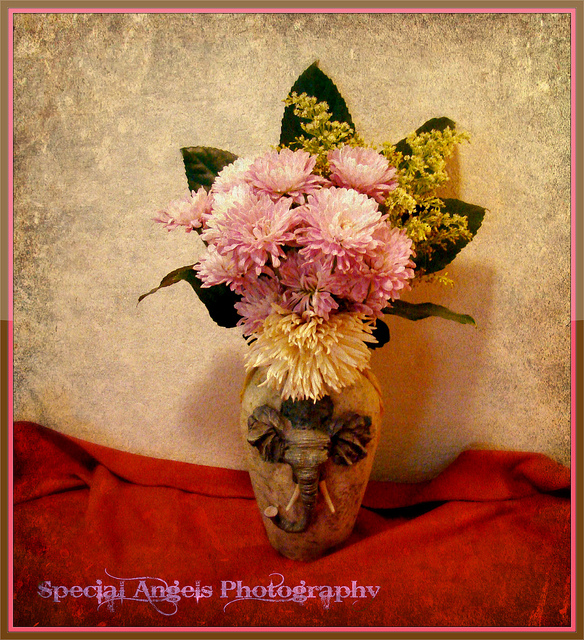Identify and read out the text in this image. Special Angeis Photographv 